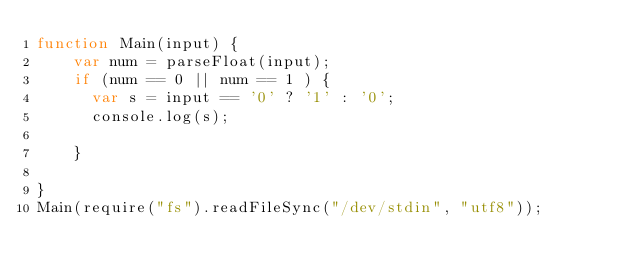Convert code to text. <code><loc_0><loc_0><loc_500><loc_500><_JavaScript_>function Main(input) {
    var num = parseFloat(input);
    if (num == 0 || num == 1 ) {
    	var s = input == '0' ? '1' : '0';
    	console.log(s);
        
    } 
    
}
Main(require("fs").readFileSync("/dev/stdin", "utf8"));</code> 